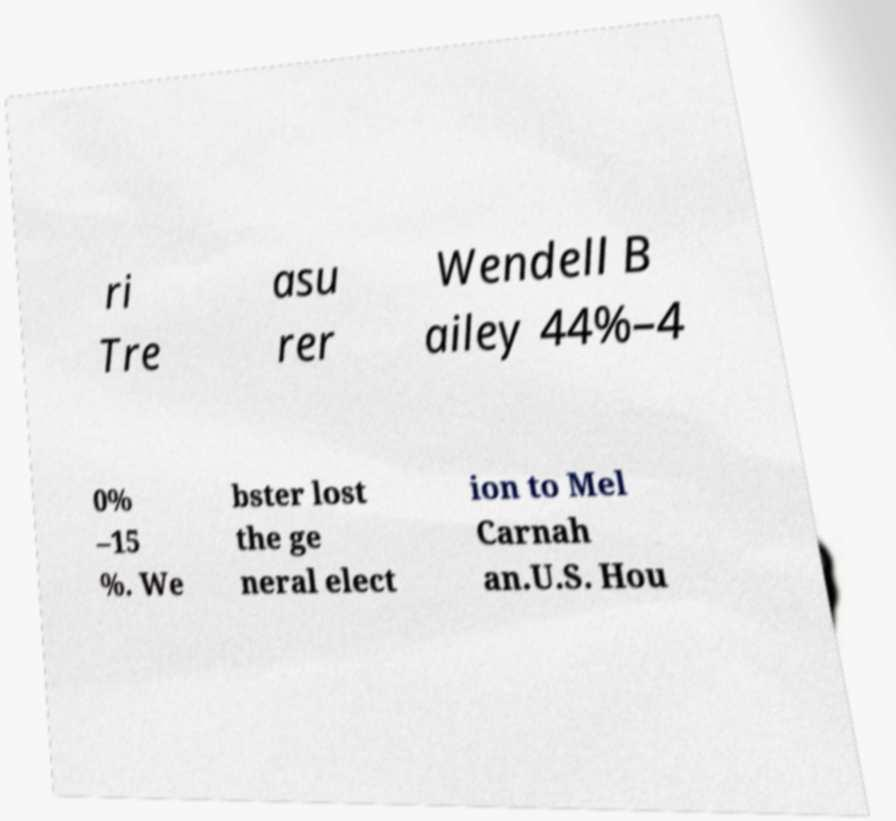What messages or text are displayed in this image? I need them in a readable, typed format. ri Tre asu rer Wendell B ailey 44%–4 0% –15 %. We bster lost the ge neral elect ion to Mel Carnah an.U.S. Hou 